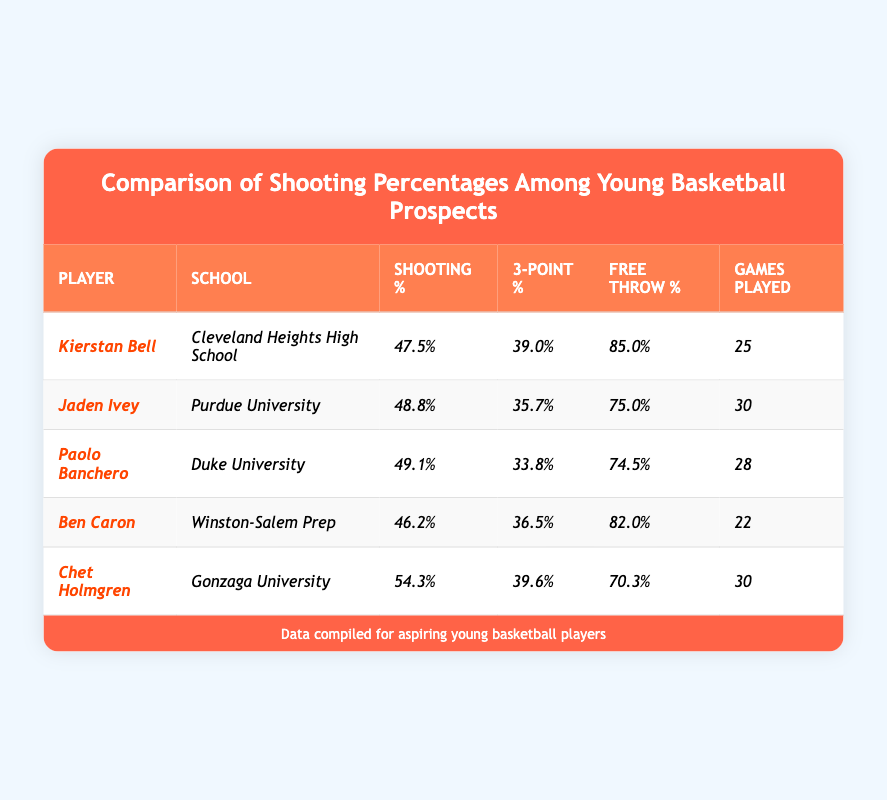What is Kierstan Bell's free throw percentage? The table shows that Kierstan Bell's free throw percentage is listed as 85.0%.
Answer: 85.0% Which player has the highest shooting percentage? According to the table, Chet Holmgren has the highest shooting percentage at 54.3%.
Answer: Chet Holmgren How many games did Jaden Ivey play? The table specifies that Jaden Ivey played 30 games.
Answer: 30 What is the difference between the shooting percentages of Kierstan Bell and Jaden Ivey? Kierstan Bell's shooting percentage is 47.5% and Jaden Ivey's is 48.8%. The difference is calculated as 48.8% - 47.5% = 1.3%.
Answer: 1.3% Which player has a higher three-point percentage, Ben Caron or Paolo Banchero? Ben Caron's three-point percentage is 36.5% and Paolo Banchero's is 33.8%. Since 36.5% is greater than 33.8%, Ben Caron has the higher percentage.
Answer: Ben Caron What is the average free throw percentage of all players listed in the table? The free throw percentages are 85.0%, 75.0%, 74.5%, 82.0%, and 70.3%. First, sum these values: 85.0 + 75.0 + 74.5 + 82.0 + 70.3 = 386.8. Then, divide by the number of players (5): 386.8 / 5 = 77.36%.
Answer: 77.36% Is it true that all players listed have a shooting percentage above 45%? By examining the table, we see the shooting percentages: 47.5%, 48.8%, 49.1%, 46.2%, and 54.3%. All of these values are greater than 45%, so the statement is true.
Answer: Yes Who played the fewest games and what is that number? The table shows that Ben Caron played the fewest games at 22.
Answer: 22 Which player has the lowest free throw percentage? The table indicates that Paolo Banchero has the lowest free throw percentage at 74.5%.
Answer: Paolo Banchero If we consider only players with a shooting percentage above 48%, how many games did they play in total? The players with shooting percentages above 48% are Jaden Ivey (30 games), Paolo Banchero (28 games), and Chet Holmgren (30 games). Summing those: 30 + 28 + 30 = 88 games in total.
Answer: 88 What is the combined average shooting percentage of Kierstan Bell and Ben Caron? Kierstan Bell's shooting percentage is 47.5% and Ben Caron's is 46.2%. Adding these gives: 47.5 + 46.2 = 93.7%. Dividing by 2 accounts for the two players: 93.7% / 2 = 46.85%.
Answer: 46.85% 